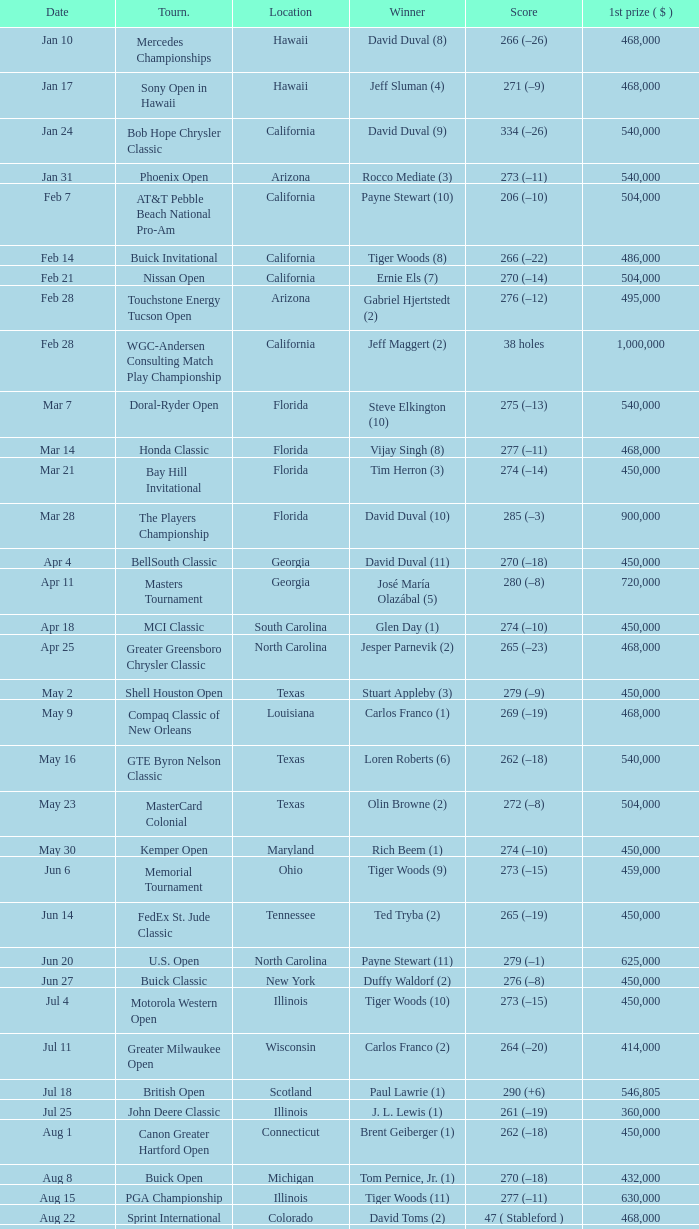What is the date of the Greater Greensboro Chrysler Classic? Apr 25. 